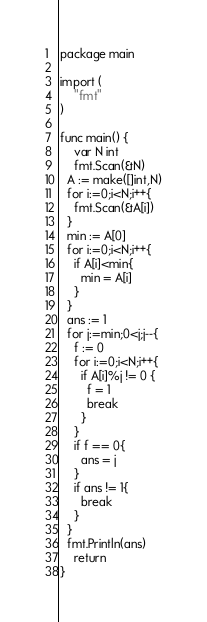<code> <loc_0><loc_0><loc_500><loc_500><_Go_>package main

import (
	"fmt"
)

func main() {
	var N int
	fmt.Scan(&N)
  A := make([]int,N)
  for i:=0;i<N;i++{
    fmt.Scan(&A[i])
  }
  min := A[0]
  for i:=0;i<N;i++{
    if A[i]<min{
      min = A[i]
    }
  }
  ans := 1
  for j:=min;0<j;j--{
    f := 0
    for i:=0;i<N;i++{
      if A[i]%j != 0 {
        f = 1
        break
      }
    }
    if f == 0{
      ans = j
    }
    if ans != 1{
      break
    }
  }
  fmt.Println(ans)
	return
}
</code> 